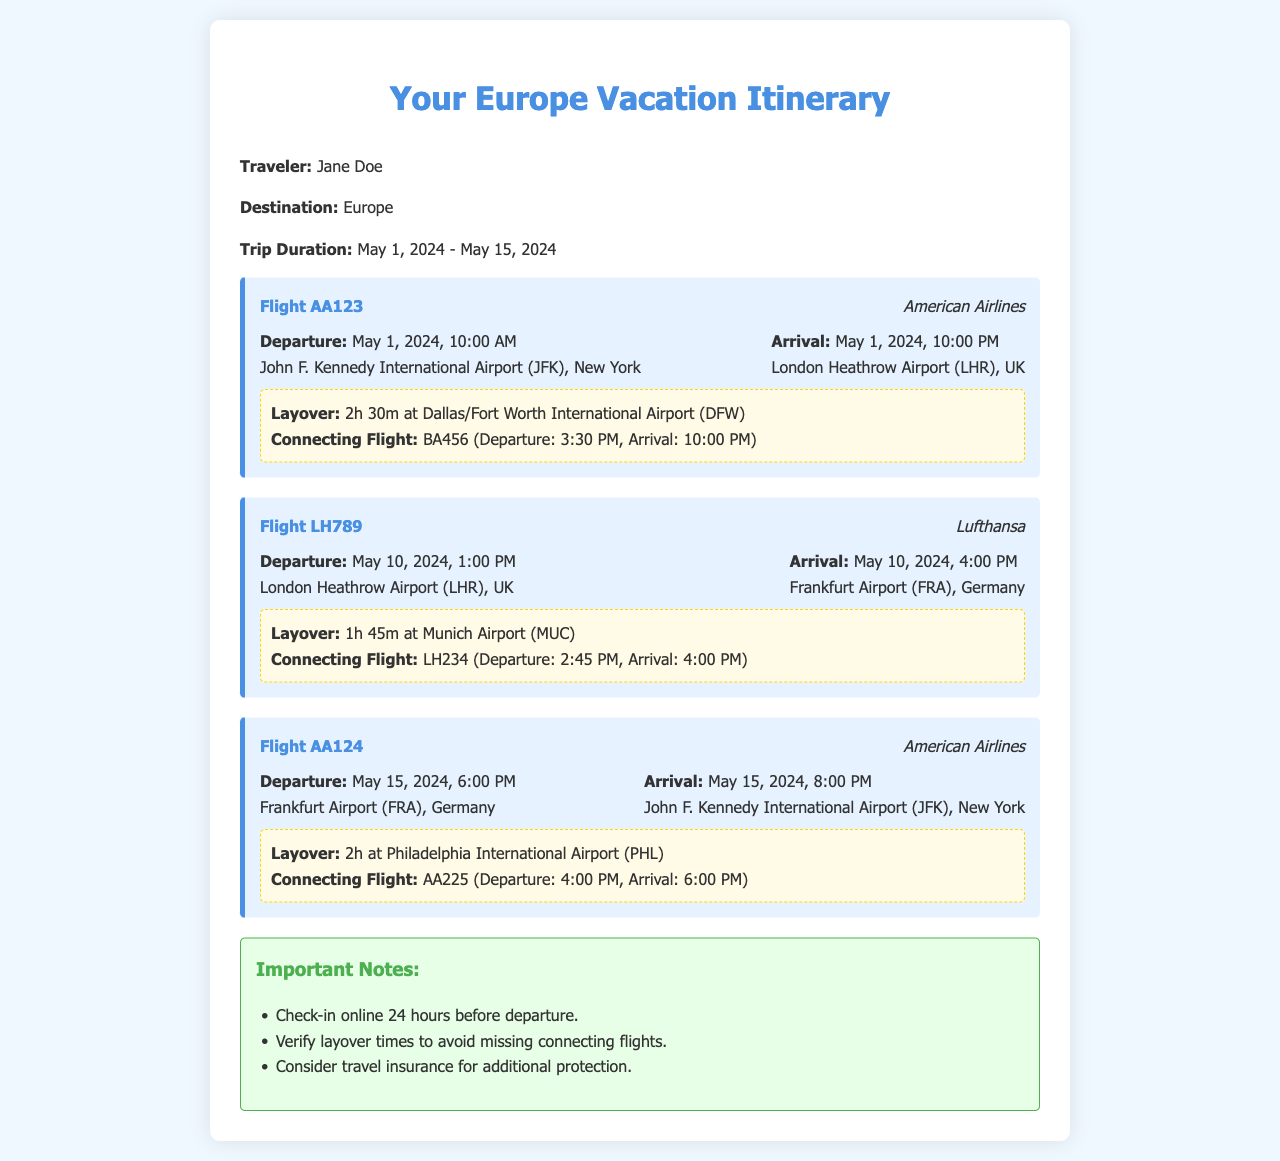What is the departure date for the first flight? The departure date for the first flight is found in the flight card with the flight number AA123, which states May 1, 2024.
Answer: May 1, 2024 What is the arrival time of the first flight? The arrival time of the first flight is indicated in the flight card for AA123, which shows the time as 10:00 PM.
Answer: 10:00 PM How long is the layover for the first flight? The layover duration can be found in the layover section of the AA123 flight card, stating it is 2h 30m.
Answer: 2h 30m Which airline operates the second flight? The airline for the second flight (LH789) is mentioned in the flight card, which lists it as Lufthansa.
Answer: Lufthansa What is the arrival airport for the last flight? The arrival airport for the last flight (AA124) is specified in the flight card, which indicates it is John F. Kennedy International Airport (JFK).
Answer: John F. Kennedy International Airport (JFK) How long is the layover for the Lufthansa flight? The layover time for the Lufthansa flight is found under the layover details in flight LH789, which states it is 1h 45m.
Answer: 1h 45m What is one important note regarding check-in? One of the important notes regarding check-in is specified in the notes section, indicating that passengers should check in online 24 hours before departure.
Answer: Check-in online 24 hours before departure When is the trip duration for the vacation? The trip duration is summarized in the introductory part of the document, stating that it is between May 1, 2024 and May 15, 2024.
Answer: May 1, 2024 - May 15, 2024 What is the connecting flight number for the first flight? The connecting flight number for the first flight (AA123) is found in the layover details, which lists it as BA456.
Answer: BA456 